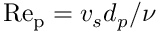Convert formula to latex. <formula><loc_0><loc_0><loc_500><loc_500>R e _ { p } = v _ { s } d _ { p } / \nu</formula> 